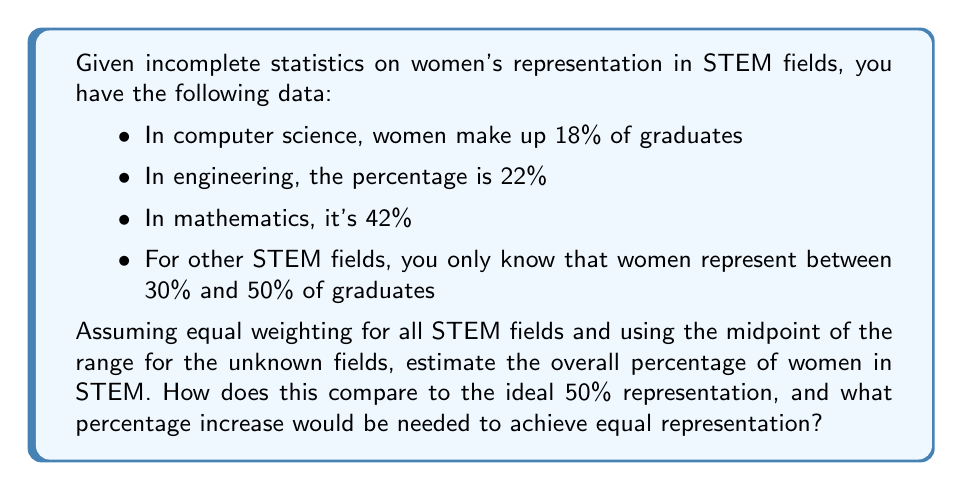Show me your answer to this math problem. To solve this problem, we'll follow these steps:

1. Calculate the average percentage for the known fields:
   $$(18\% + 22\% + 42\%) \div 3 = 27.33\%$$

2. Use the midpoint of the range for unknown fields:
   $$(30\% + 50\%) \div 2 = 40\%$$

3. Assuming equal weighting, calculate the overall percentage:
   $$(27.33\% + 40\%) \div 2 = 33.67\%$$

4. Compare to the ideal 50% representation:
   $$50\% - 33.67\% = 16.33\%$$ difference

5. Calculate the percentage increase needed:
   $$\text{Percentage increase} = \frac{\text{Difference}}{\text{Current percentage}} \times 100\%$$
   $$= \frac{16.33\%}{33.67\%} \times 100\% = 48.50\%$$

This analysis shows that women are underrepresented in STEM fields based on the available data, and a significant increase is needed to achieve equal representation.
Answer: 33.67% current representation; 48.50% increase needed for equality 